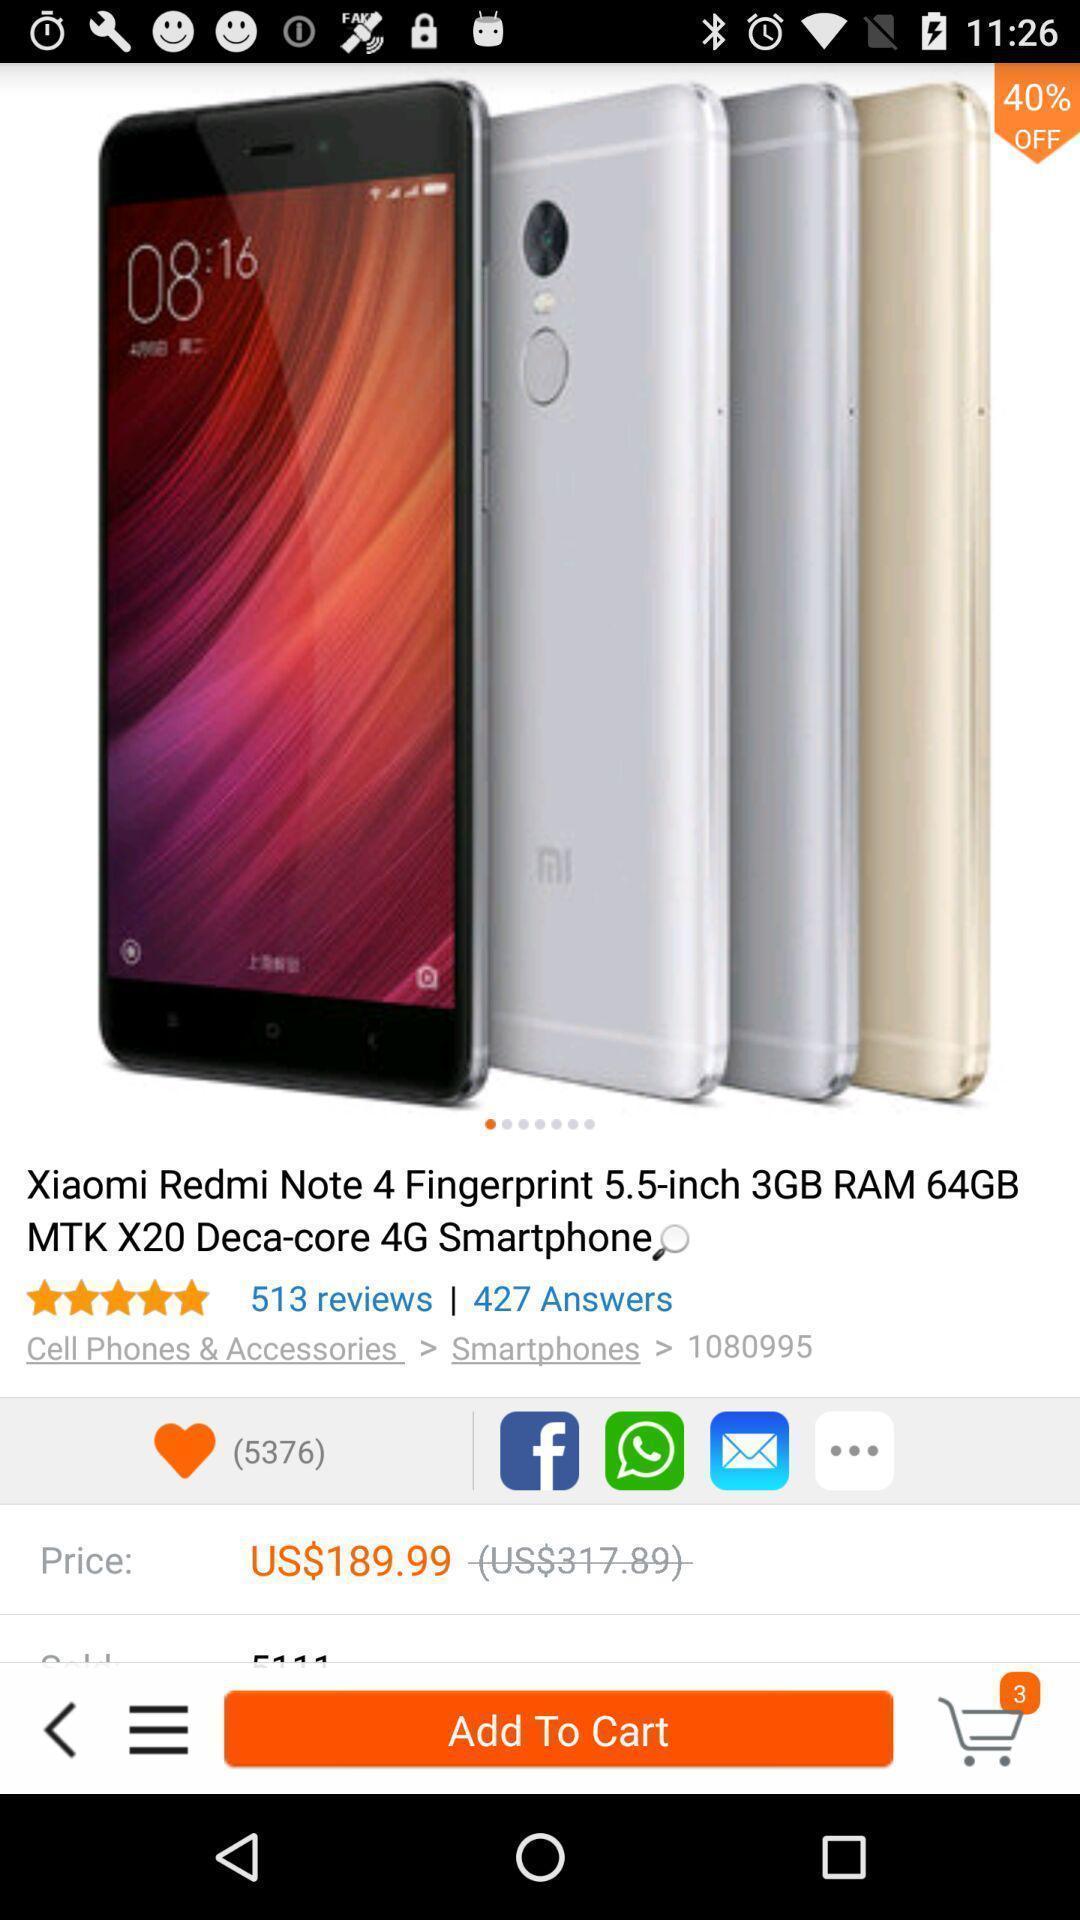Describe the content in this image. Screen page displaying the details of mobile in shopping application. 